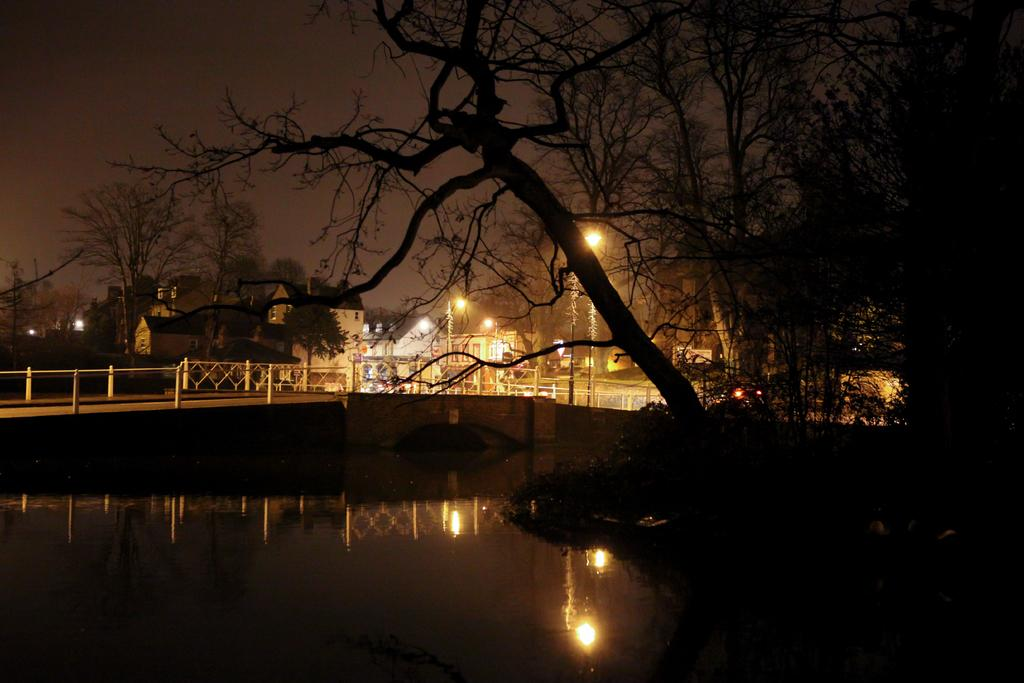What type of vegetation can be seen in the image? There are dried trees in the image. What else is visible in the image besides the trees? There is water visible in the image. What can be seen in the background of the image? There are light poles, buildings, and the sky visible in the background of the image. How does the hen start its day in the image? There is no hen present in the image, so it is not possible to answer that question. 